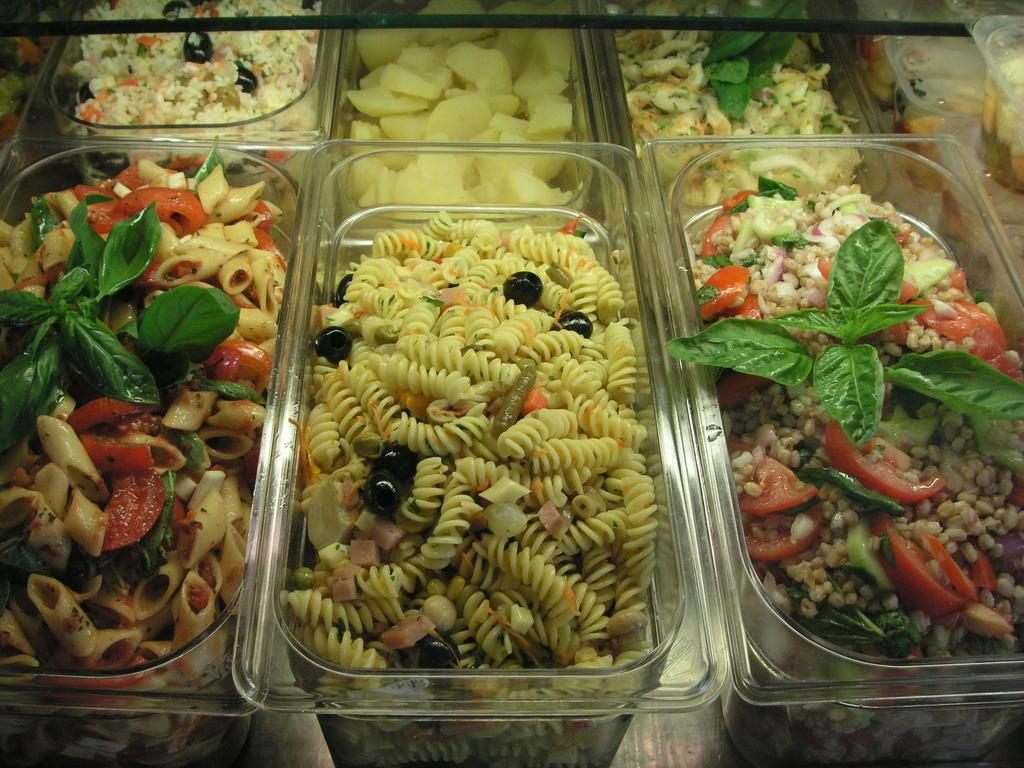What is contained within the baskets in the image? There are baskets with food in the image. Can you describe the appearance of the food? The food is colorful. Where are the baskets located in the image? The baskets are on a surface. What is the name of the girl holding the yarn in the image? There are no girls or yarn present in the image; it only features baskets with colorful food. 